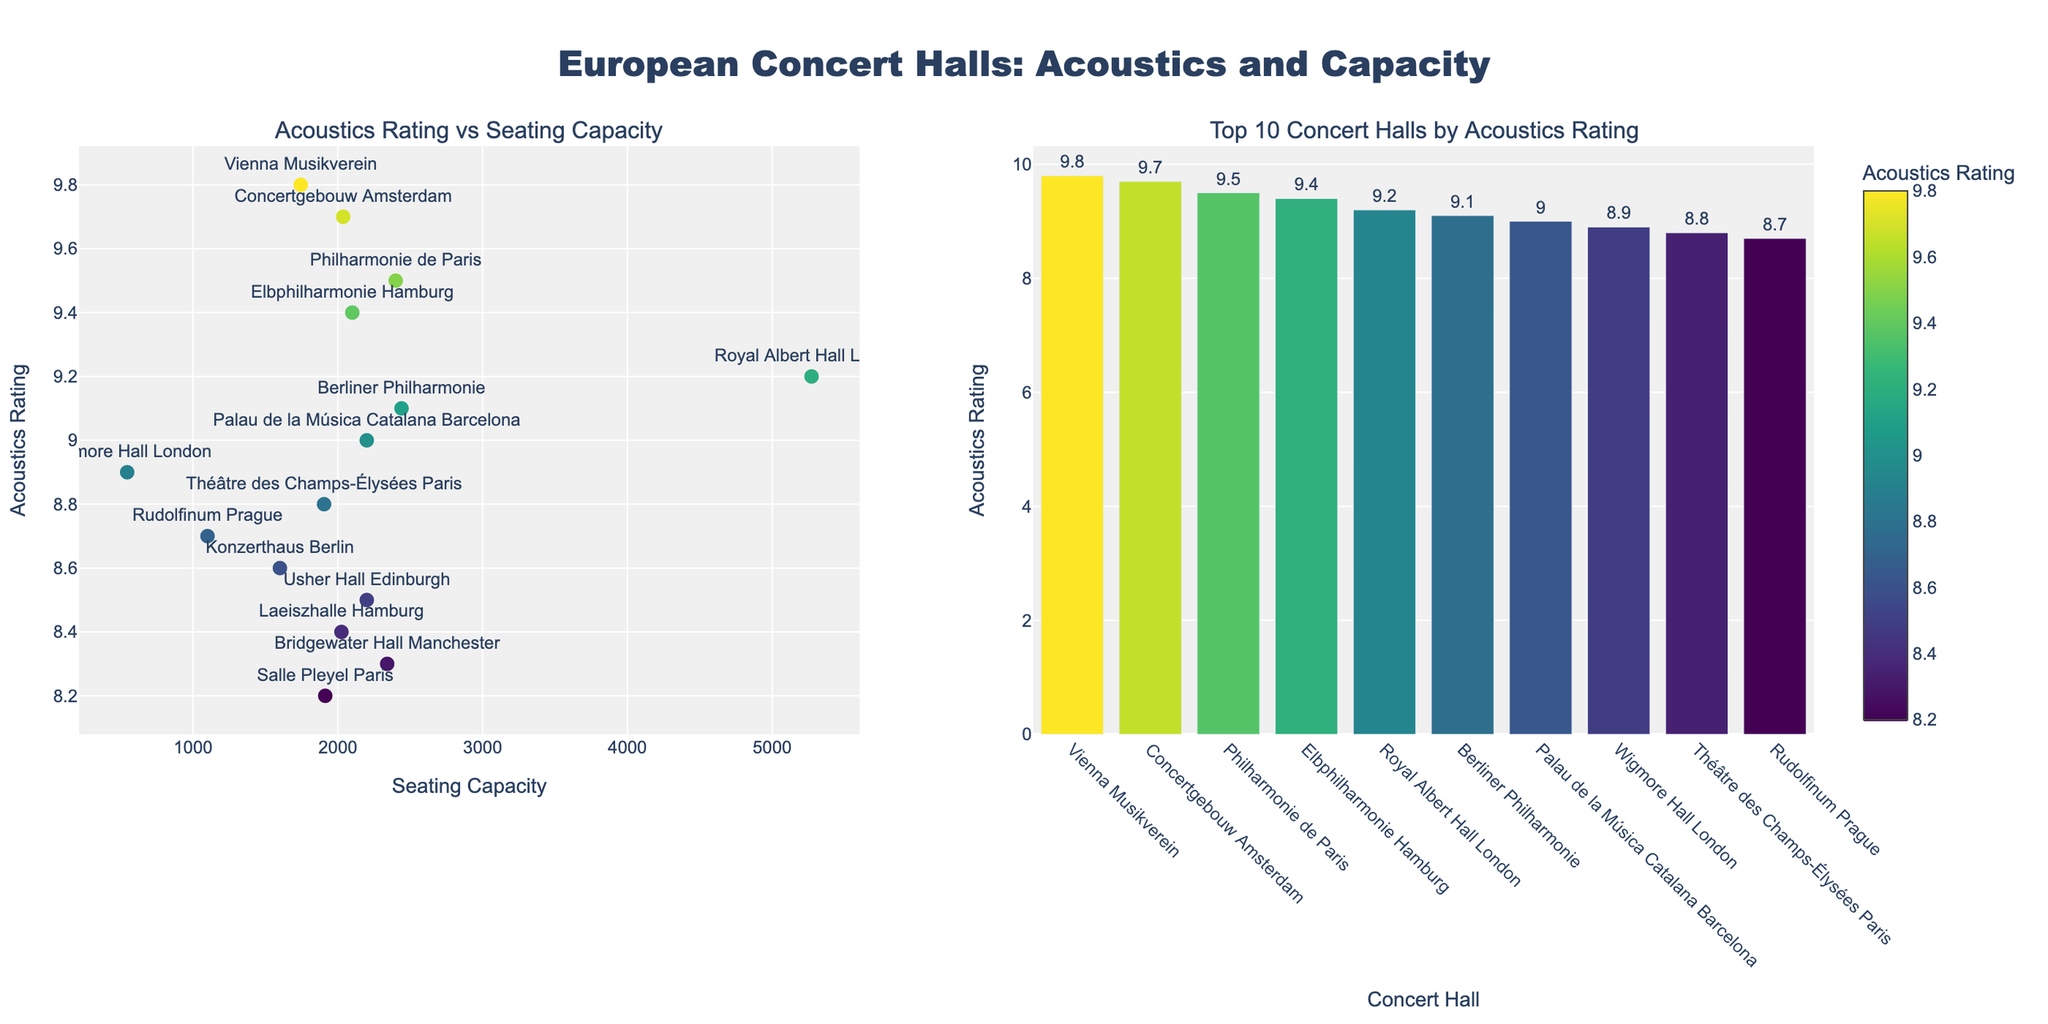What's the highest acoustics rating in the scatter plot? Observing the scatter plot, the highest acoustics rating is shown as 9.8 for the Vienna Musikverein.
Answer: 9.8 What is the seating capacity of the concert hall with the highest acoustics rating? The highest acoustics rating, 9.8, belongs to Vienna Musikverein which has a seating capacity of 1,744 seats, as seen in the scatter plot.
Answer: 1,744 Which concert hall has the largest seating capacity? Observing the scatter plot, Royal Albert Hall in London has the largest seating capacity of 5,272 seats.
Answer: Royal Albert Hall How many concert halls have an acoustics rating of 9.0 or above? Counting the number of markers in the scatter plot with acoustics rating equal to or above 9.0, we see there are 7 such concert halls.
Answer: 7 What is the average acoustics rating of the top 3 concert halls by rating? The top 3 concert halls by rating are Vienna Musikverein (9.8), Concertgebouw Amsterdam (9.7), and Philharmonie de Paris (9.5). Adding these ratings and then dividing by 3 gives (9.8 + 9.7 + 9.5)/3 = 9.67.
Answer: 9.67 Which concert hall in Paris has a higher acoustics rating, Philharmonie de Paris or Théâtre des Champs-Élysées? Comparing the acoustics ratings, Philharmonie de Paris has a rating of 9.5, while Théâtre des Champs-Élysées has a rating of 8.8. Therefore, Philharmonie de Paris has the higher rating.
Answer: Philharmonie de Paris What's the relationship between seating capacity and acoustics rating in the scatter plot? By observing the scatter plot, there isn't a clear pattern or trend indicating a relationship between seating capacity and acoustics rating. The data points are scattered without a consistent increase or decrease across either dimension.
Answer: No clear relationship Which concert hall ranks last in acoustics rating within the top 10 listed bars? The top 10 concert halls by acoustics rating are shown in the bar plot, and the concert hall with the lowest rating within these is Rudolfinum Prague with a rating of 8.7.
Answer: Rudolfinum Prague What is the difference in acoustics rating between the Vienna Musikverein and Wigmore Hall London? Vienna Musikverein has a rating of 9.8, and Wigmore Hall London has a rating of 8.9. The difference is 9.8 - 8.9 = 0.9.
Answer: 0.9 Which concert hall in Berlin is mentioned, and what is its acoustics rating and seating capacity? The scatter plot shows that Berliner Philharmonie is the concert hall in Berlin. It has an acoustics rating of 9.1 and a seating capacity of 2,440 seats.
Answer: Berliner Philharmonie 9.1 2,440 